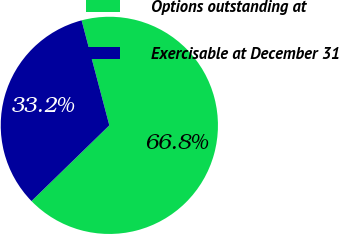<chart> <loc_0><loc_0><loc_500><loc_500><pie_chart><fcel>Options outstanding at<fcel>Exercisable at December 31<nl><fcel>66.83%<fcel>33.17%<nl></chart> 